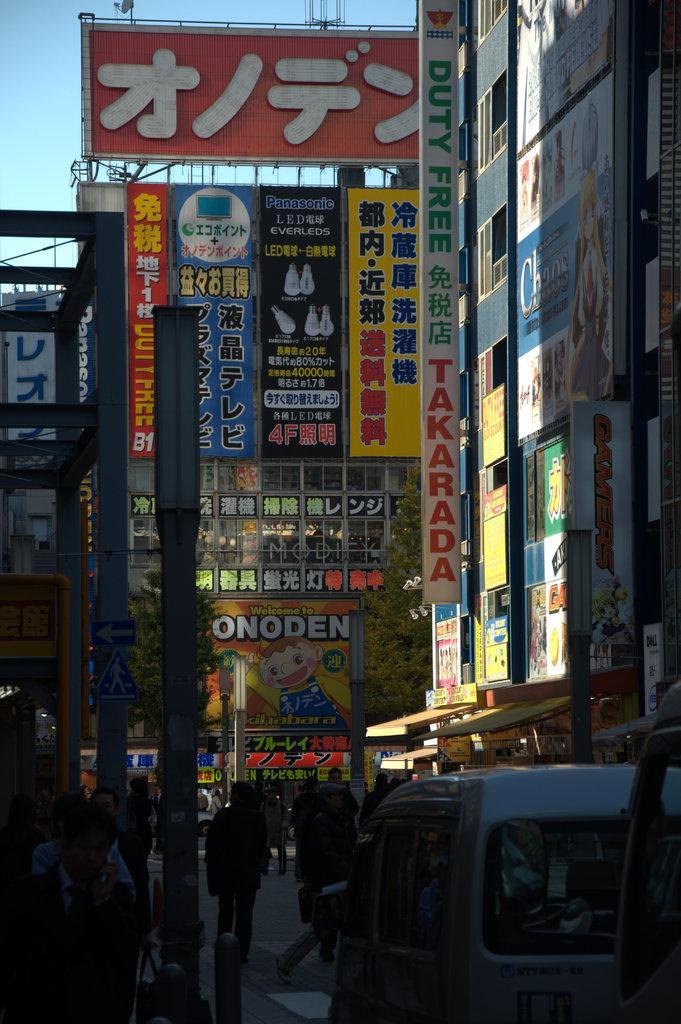Can you describe this image briefly? In this image we can see some group of persons walking on road and there are some vehicles moving on road and in the background of the image there are some buildings to which there are some posters attached and top of the image there is clear sky. 